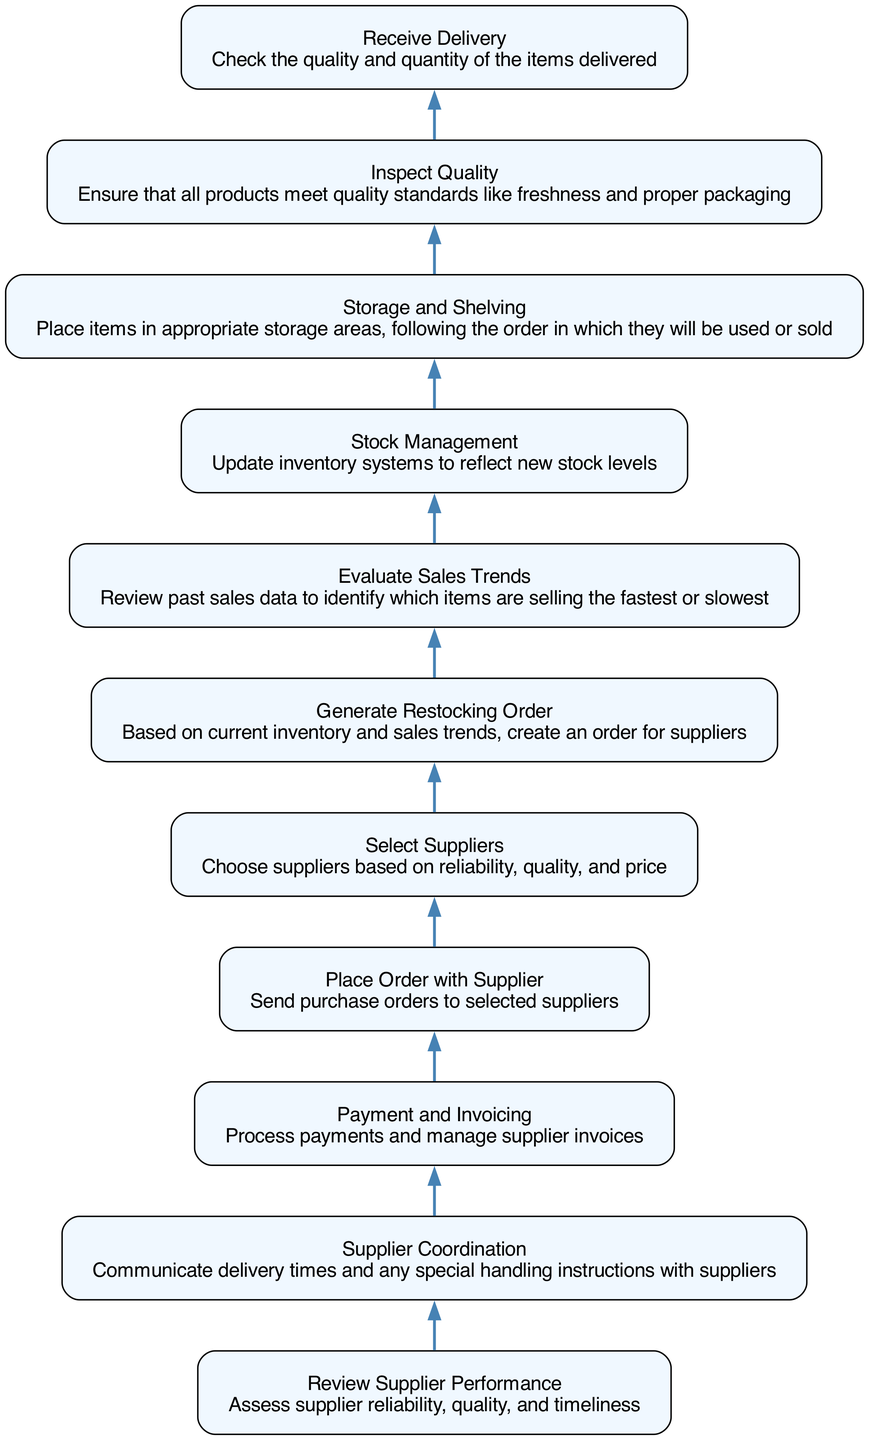What is the first step in the flowchart? The flowchart begins with the "Receive Delivery" step, which indicates the starting point of the process.
Answer: Receive Delivery How many nodes are there in total? Counting all the unique steps presented in the flowchart, there are 11 nodes representing different stages in the Supplier Relationship and Restocking Schedule.
Answer: 11 Which step comes after "Evaluation Sales Trends"? Based on the flow direction in the diagram, "Generate Restocking Order" follows "Evaluate Sales Trends" as the next action to be taken based on the evaluated sales data.
Answer: Generate Restocking Order What is the last step in the process? The process culminates at "Receive Delivery," which is the initiating action, indicating that the cycle continues with the delivery each time it is completed.
Answer: Receive Delivery Which node leads to "Payment and Invoicing"? The node "Place Order with Supplier" leads into "Payment and Invoicing," indicating that once an order is placed, the next action is to handle payment and invoicing.
Answer: Place Order with Supplier What is the relationship between "Supplier Coordination" and "Review Supplier Performance"? "Review Supplier Performance" precedes "Supplier Coordination" and indicates that performance assessments are made before communicating with suppliers about deliveries.
Answer: Review Supplier Performance What comes directly before "Stock Management"? The step that comes directly before "Stock Management" is "Storage and Shelving," indicating that after placing items on shelves, stock management updates the inventory system.
Answer: Storage and Shelving How many steps are there between "Select Suppliers" and "Receive Delivery"? Moving from "Select Suppliers" up to "Receive Delivery," there are a total of 8 steps in between that outline the entire process of restocking and delivery confirmation.
Answer: 8 What is the node that connects "Payment and Invoicing" and "Supplier Coordination"? "Payment and Invoicing" is linked to "Supplier Coordination," meaning that once payments are processed, coordination with suppliers about delivery times follows next.
Answer: Supplier Coordination 